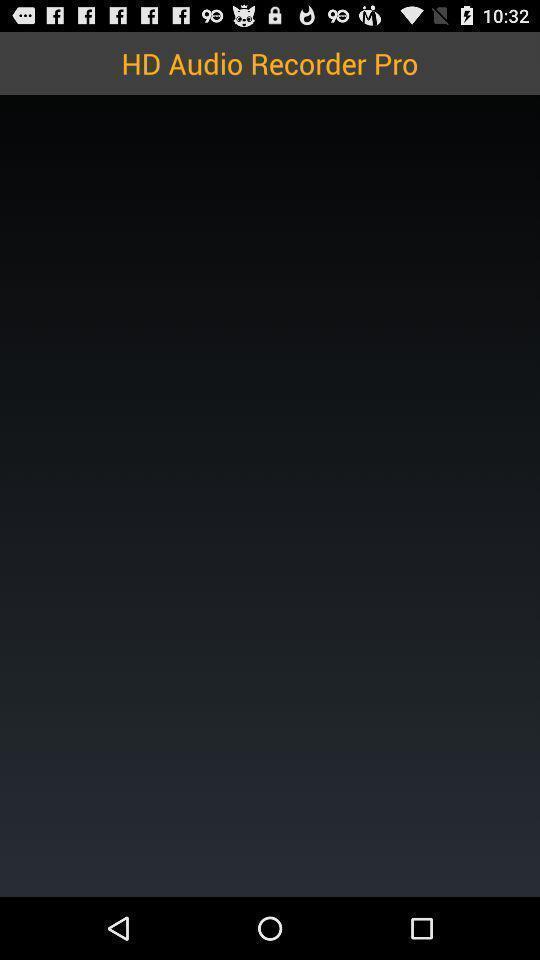Provide a description of this screenshot. Page of audio recorder pro of the app. 